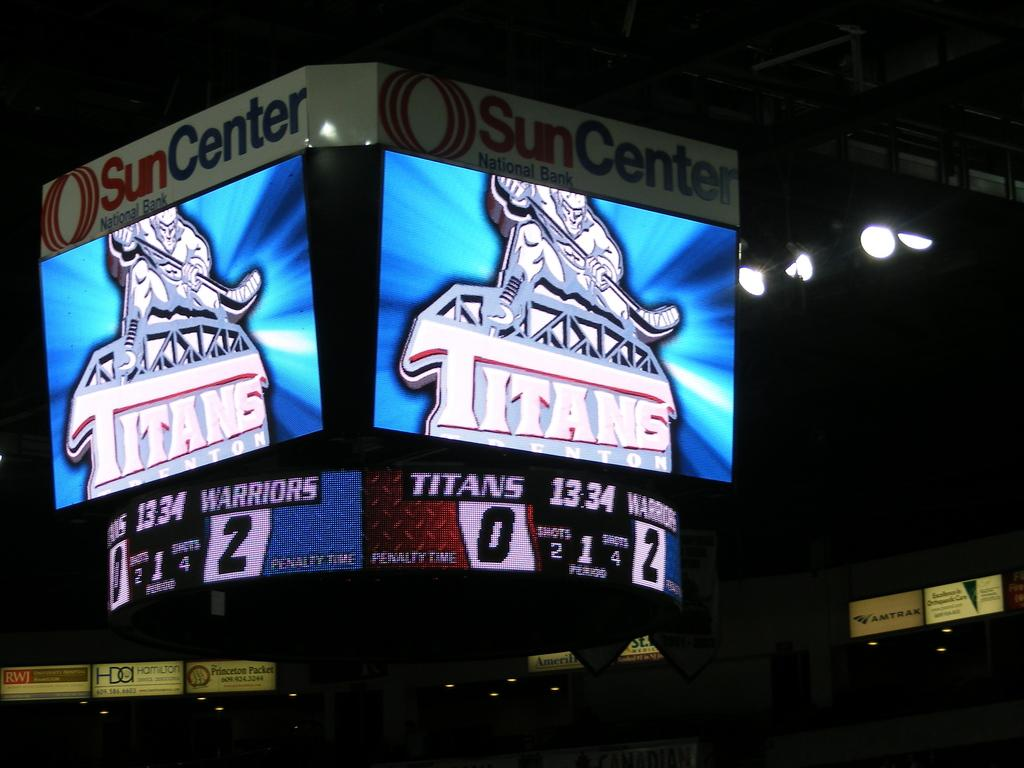What is the main feature of the image? There is a huge scoreboard in the image. What can be observed about the scoreboard? The scoreboard has lights. How would you describe the lighting conditions in the image? The image is set in a dark environment. Can you tell me how many robins are perched on the scoreboard in the image? There are no robins present in the image; it features a huge scoreboard with lights in a dark environment. What type of adjustment is being made to the scoreboard in the image? There is no indication of any adjustment being made to the scoreboard in the image. 